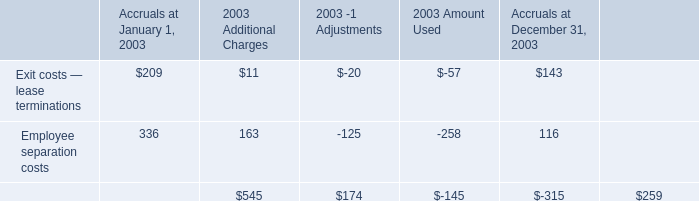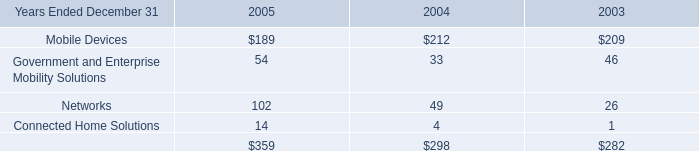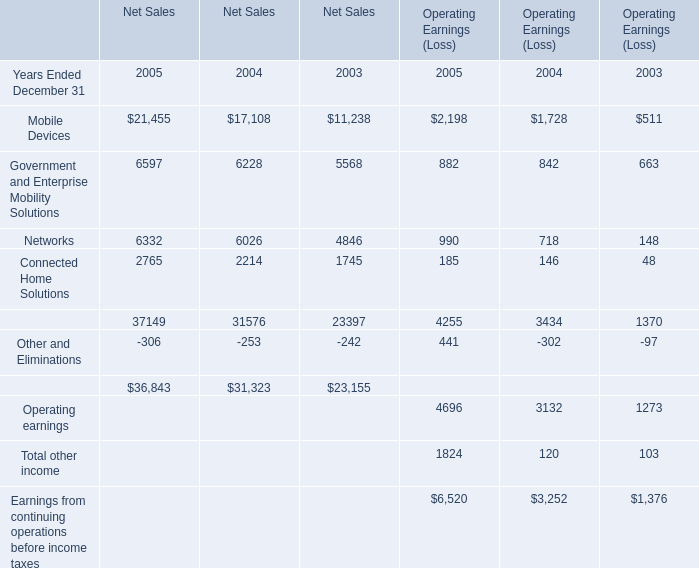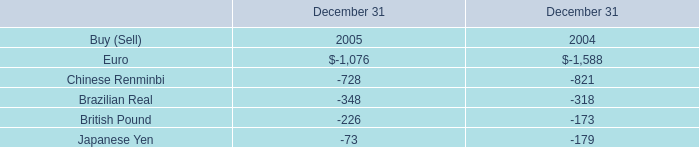what's the total amount of Euro of December 31 2004, and Mobile Devices of Net Sales 2004 ? 
Computations: (1588.0 + 17108.0)
Answer: 18696.0. 